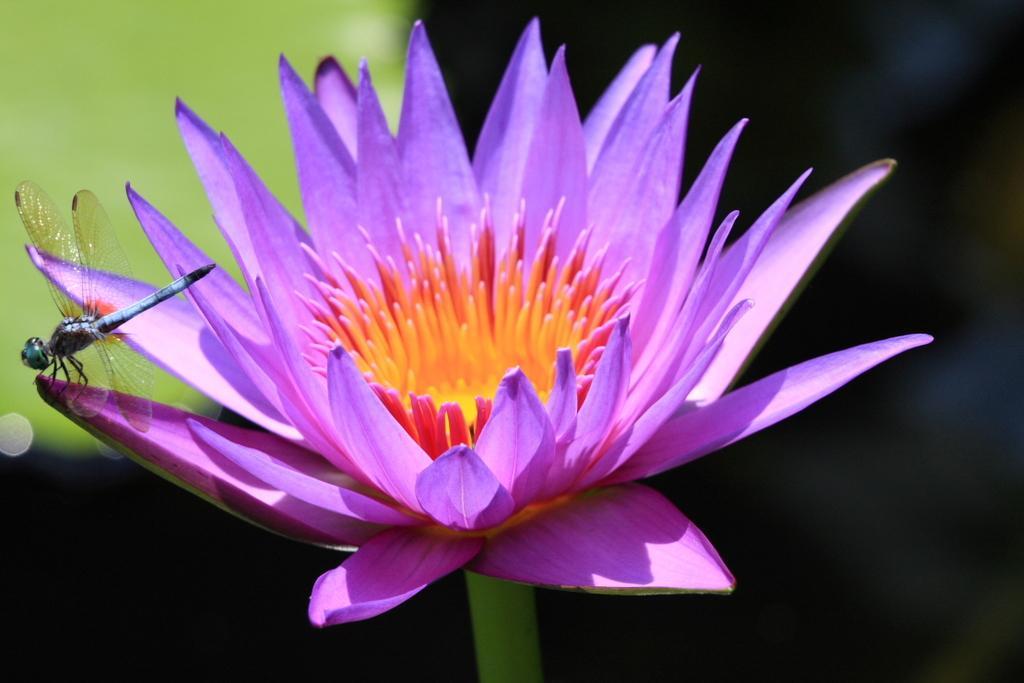Could you give a brief overview of what you see in this image? In this image I can see the purple color flower and an insect is on it. Background is in green and black color. 